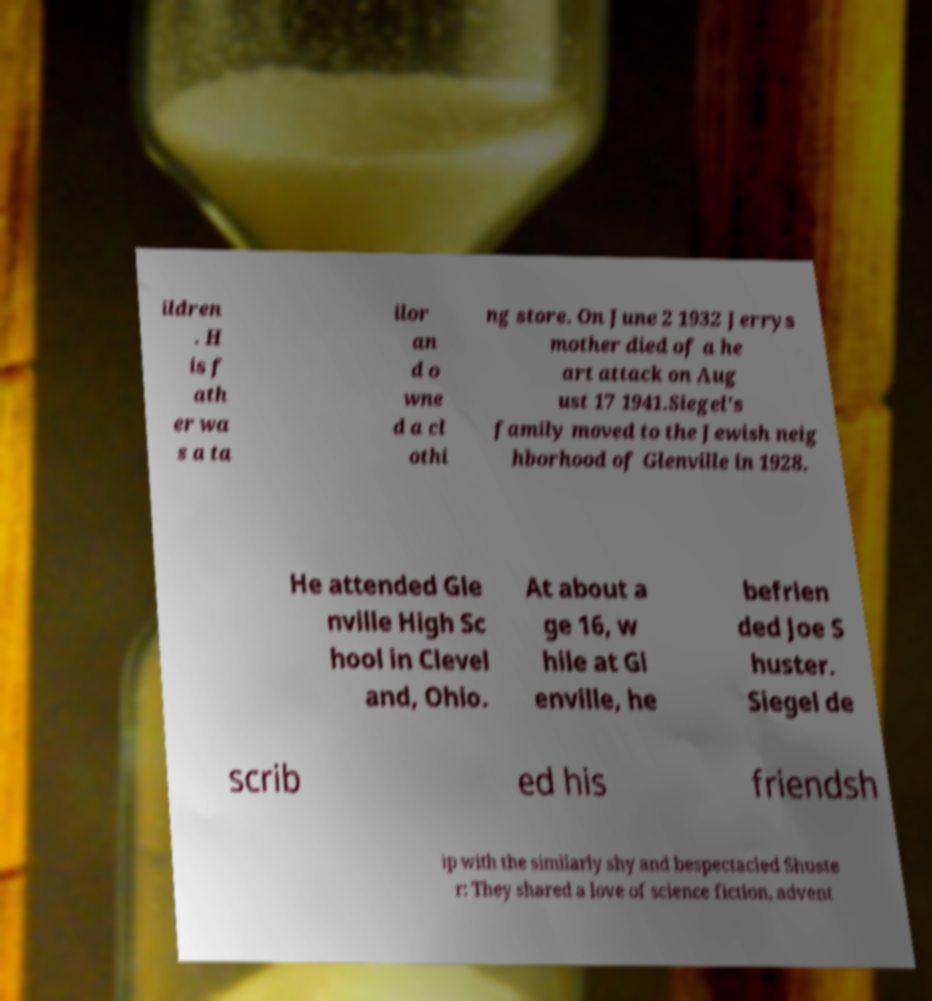Can you read and provide the text displayed in the image?This photo seems to have some interesting text. Can you extract and type it out for me? ildren . H is f ath er wa s a ta ilor an d o wne d a cl othi ng store. On June 2 1932 Jerrys mother died of a he art attack on Aug ust 17 1941.Siegel's family moved to the Jewish neig hborhood of Glenville in 1928. He attended Gle nville High Sc hool in Clevel and, Ohio. At about a ge 16, w hile at Gl enville, he befrien ded Joe S huster. Siegel de scrib ed his friendsh ip with the similarly shy and bespectacled Shuste r: They shared a love of science fiction, advent 